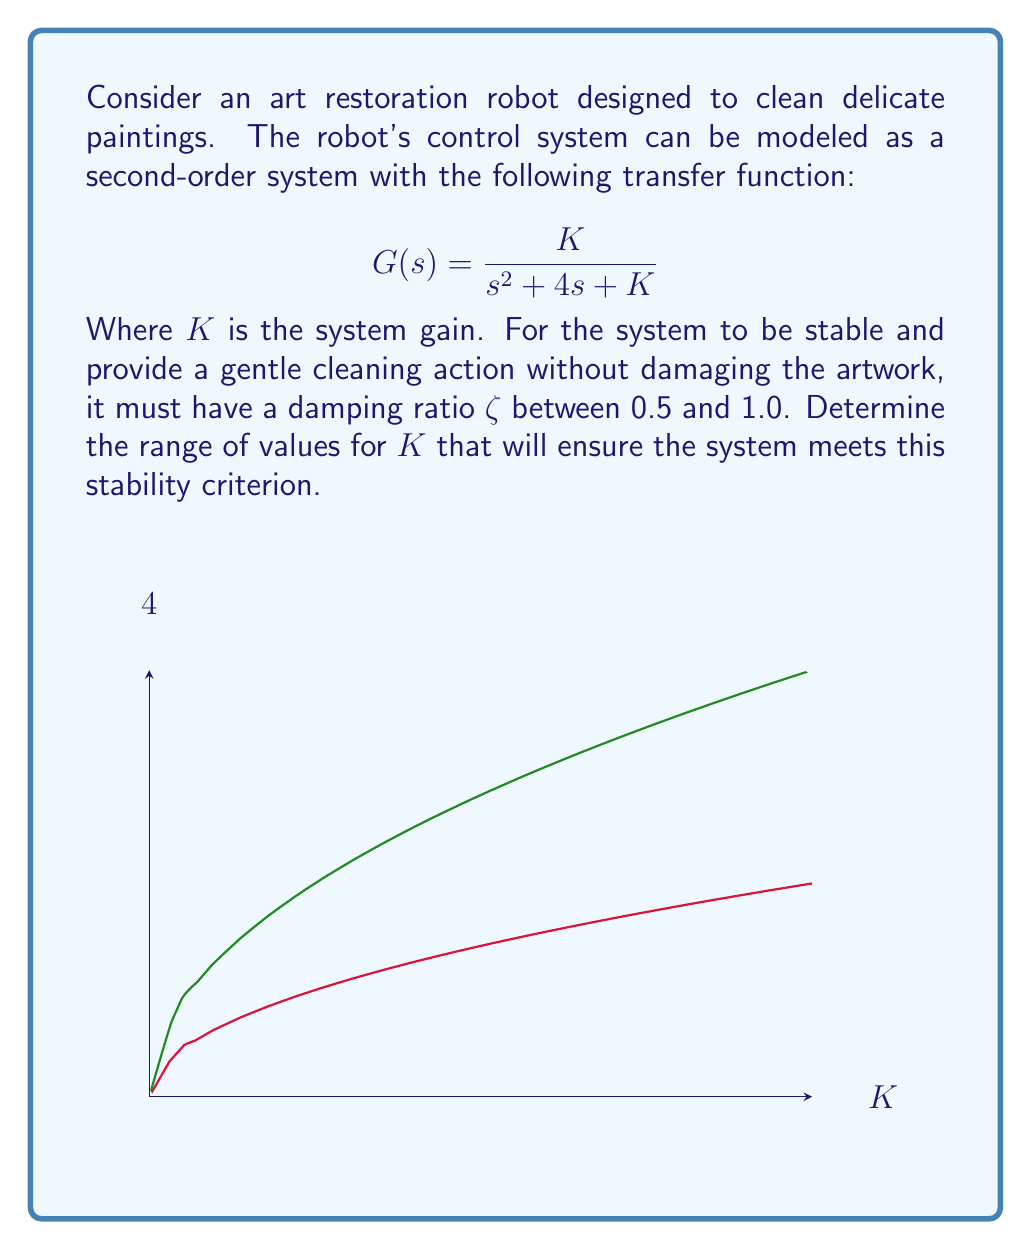Provide a solution to this math problem. To solve this problem, we'll follow these steps:

1) For a second-order system with transfer function $\frac{\omega_n^2}{s^2 + 2\zeta\omega_n s + \omega_n^2}$, we can compare it to our given transfer function:

   $$\frac{K}{s^2 + 4s + K}$$

2) From this comparison, we can deduce:
   $\omega_n^2 = K$ and $2\zeta\omega_n = 4$

3) We can express $\zeta$ in terms of $K$:
   $\zeta = \frac{4}{2\omega_n} = \frac{4}{2\sqrt{K}} = \frac{2}{\sqrt{K}}$

4) Now, we need to solve two inequalities:
   
   For $\zeta \geq 0.5$: $\frac{2}{\sqrt{K}} \geq 0.5$
   For $\zeta \leq 1.0$: $\frac{2}{\sqrt{K}} \leq 1.0$

5) Solving these inequalities:

   For $\zeta \geq 0.5$: 
   $\frac{2}{\sqrt{K}} \geq 0.5$
   $\sqrt{K} \leq 4$
   $K \leq 16$

   For $\zeta \leq 1.0$:
   $\frac{2}{\sqrt{K}} \leq 1.0$
   $\sqrt{K} \geq 2$
   $K \geq 4$

6) Combining these results, we get:

   $4 \leq K \leq 16$

This range of $K$ values will ensure the damping ratio is between 0.5 and 1.0, providing stable and gentle cleaning action for the art restoration robot.
Answer: $4 \leq K \leq 16$ 